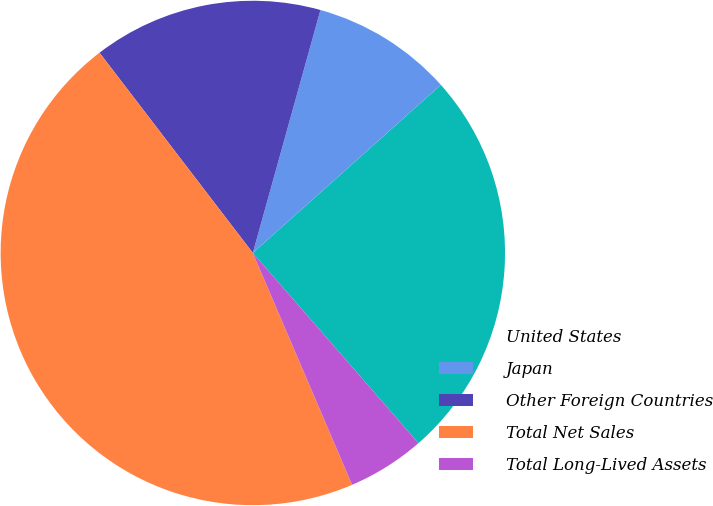Convert chart to OTSL. <chart><loc_0><loc_0><loc_500><loc_500><pie_chart><fcel>United States<fcel>Japan<fcel>Other Foreign Countries<fcel>Total Net Sales<fcel>Total Long-Lived Assets<nl><fcel>25.21%<fcel>9.07%<fcel>14.72%<fcel>46.04%<fcel>4.96%<nl></chart> 